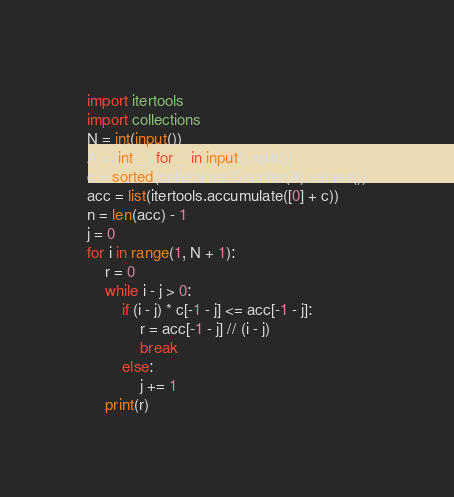Convert code to text. <code><loc_0><loc_0><loc_500><loc_500><_Python_>import itertools
import collections
N = int(input())
A = [int(_) for _ in input().split()]
c = sorted(collections.Counter(A).values())
acc = list(itertools.accumulate([0] + c))
n = len(acc) - 1
j = 0
for i in range(1, N + 1):
    r = 0
    while i - j > 0:
        if (i - j) * c[-1 - j] <= acc[-1 - j]:
            r = acc[-1 - j] // (i - j)
            break
        else:
            j += 1
    print(r)
</code> 